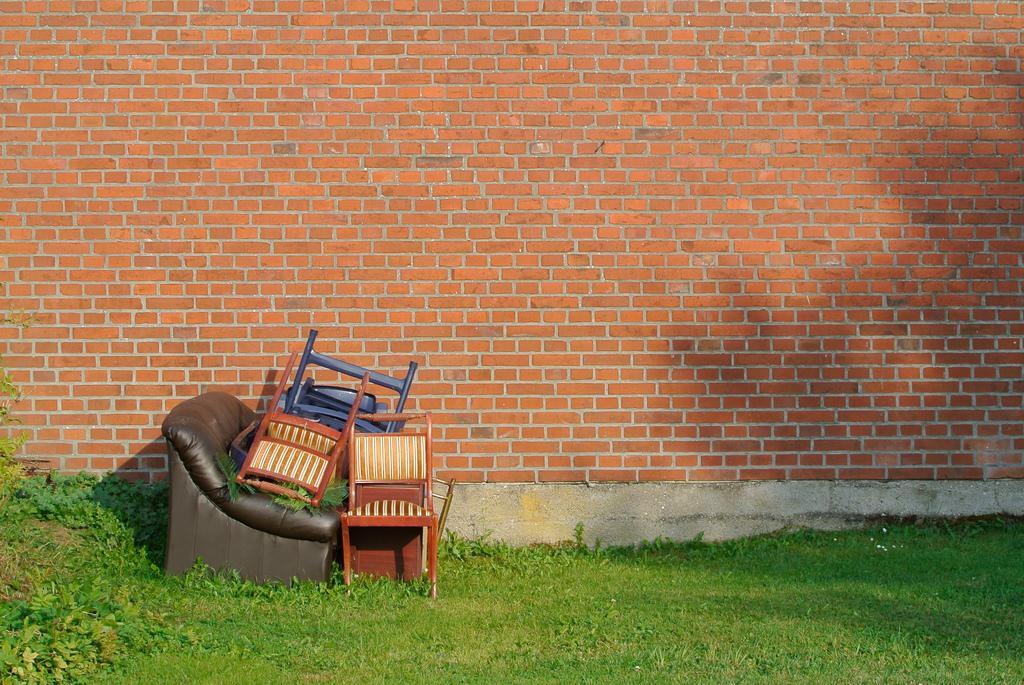Could you give a brief overview of what you see in this image? In this image we can see some chairs and other objects on the ground and we can see the grass and plants and in the background, we can see the wall. 